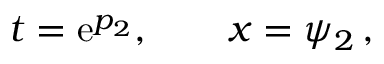<formula> <loc_0><loc_0><loc_500><loc_500>t = e ^ { p _ { 2 } } , \quad x = \psi _ { 2 } \, ,</formula> 